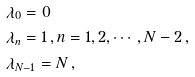Convert formula to latex. <formula><loc_0><loc_0><loc_500><loc_500>& \lambda _ { 0 } = 0 \, \\ & \lambda _ { n } = 1 \, , n = 1 , 2 , \cdots , N - 2 \, , \\ & \lambda _ { N - 1 } = N \, ,</formula> 